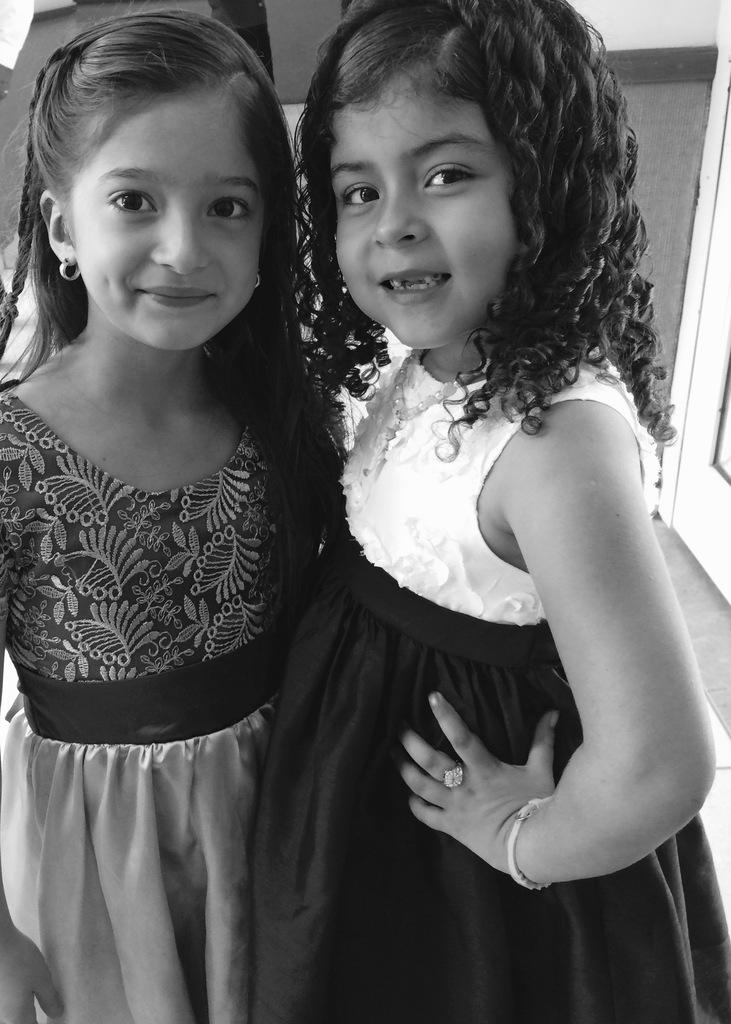How many people are in the image? There are two girls in the image. What are the girls doing in the image? The girls are standing in the image. What is the facial expression of the girls? The girls are smiling in the image. What invention is the girls using in the image? There is no invention visible in the image; it only shows two girls standing and smiling. 